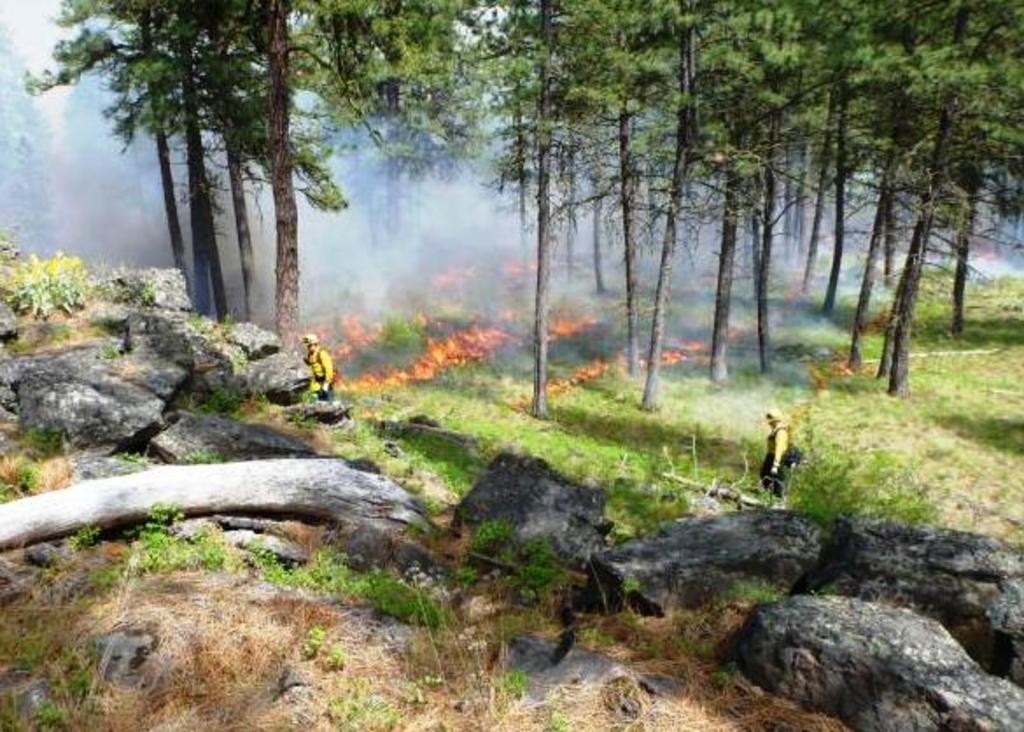Can you describe this image briefly? In this image the forest is on fire, there are two firefighters trying to put off the fire, in this image there are trees and rocks. 